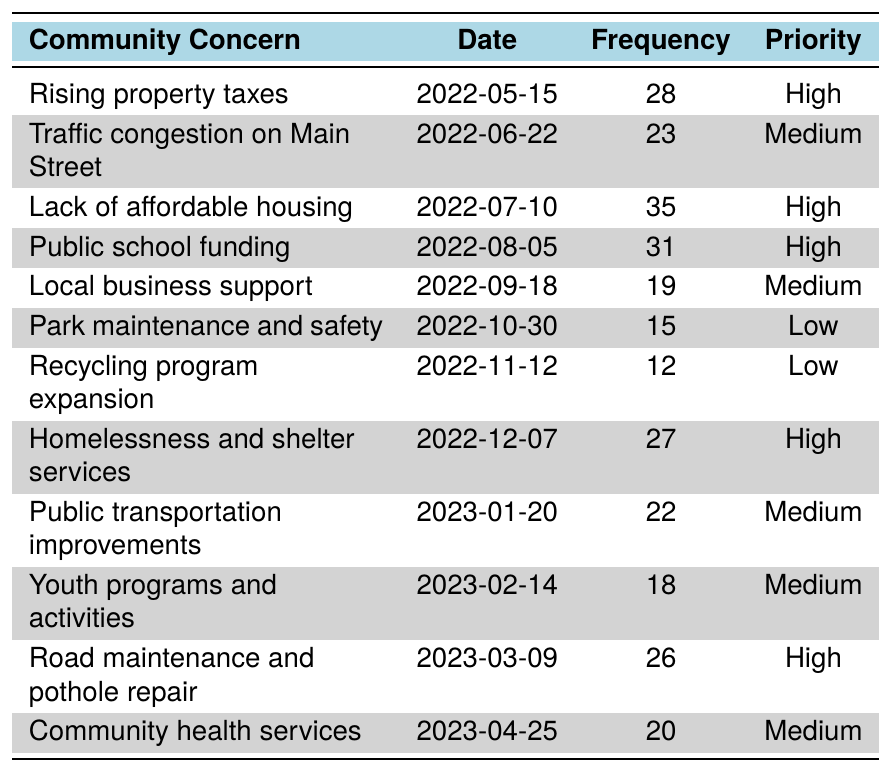What is the most frequently raised community concern in the table? By examining the "Frequency" column, we find that the highest value is 35, which corresponds to the concern "Lack of affordable housing."
Answer: Lack of affordable housing How many concerns were raised with a high priority? We can count the number of rows that have "High" in the Priority column. There are four such concerns: "Rising property taxes," "Lack of affordable housing," "Public school funding," and "Homelessness and shelter services."
Answer: 4 What percentage of the total concerns raised are considered medium priority? First, we count the total number of concerns, which is 12. Then, we find that there are five medium priority concerns: "Traffic congestion on Main Street," "Local business support," "Public transportation improvements," "Youth programs and activities," and "Community health services." Therefore, (5/12) * 100 = approximately 41.67%.
Answer: 41.67% What is the frequency difference between the highest and lowest priority concerns? The highest frequency is 35 (Lack of affordable housing) and the lowest is 12 (Recycling program expansion). The difference is 35 - 12 = 23.
Answer: 23 Are there any concerns related to public transport and how many were raised? Looking at the table, "Public transportation improvements" is the only concern related to public transport, which was raised once.
Answer: Yes, 1 Which month had the highest frequency of raised concerns and how many? The table indicates that the "Lack of affordable housing" had the highest frequency of 35 in July, making this the month with the highest frequency for a concern.
Answer: July, 35 What is the average frequency of all concerns rated as medium priority? We identify the medium priority concerns and their frequencies: 23, 19, 22, 18, and 20. Adding these gives us 102, and since there are 5 concerns, we divide 102 by 5, resulting in an average of 20.4.
Answer: 20.4 